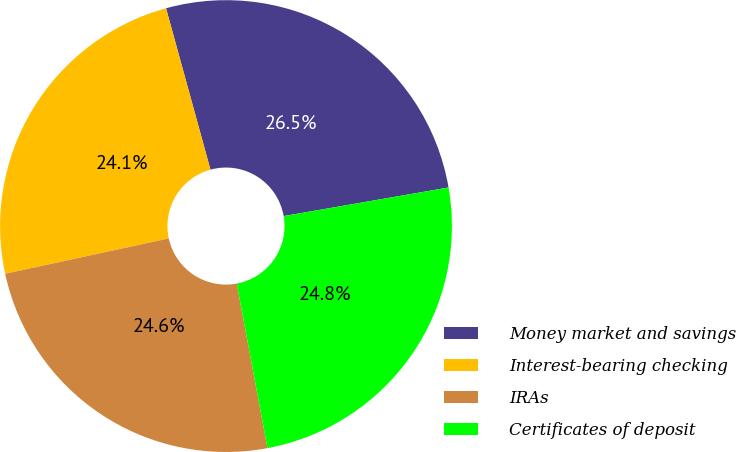Convert chart to OTSL. <chart><loc_0><loc_0><loc_500><loc_500><pie_chart><fcel>Money market and savings<fcel>Interest-bearing checking<fcel>IRAs<fcel>Certificates of deposit<nl><fcel>26.54%<fcel>24.11%<fcel>24.55%<fcel>24.79%<nl></chart> 